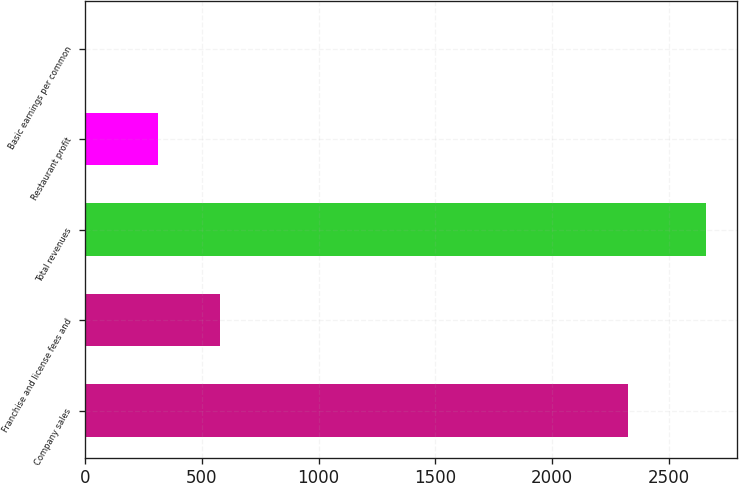<chart> <loc_0><loc_0><loc_500><loc_500><bar_chart><fcel>Company sales<fcel>Franchise and license fees and<fcel>Total revenues<fcel>Restaurant profit<fcel>Basic earnings per common<nl><fcel>2323<fcel>576.85<fcel>2659<fcel>311<fcel>0.47<nl></chart> 